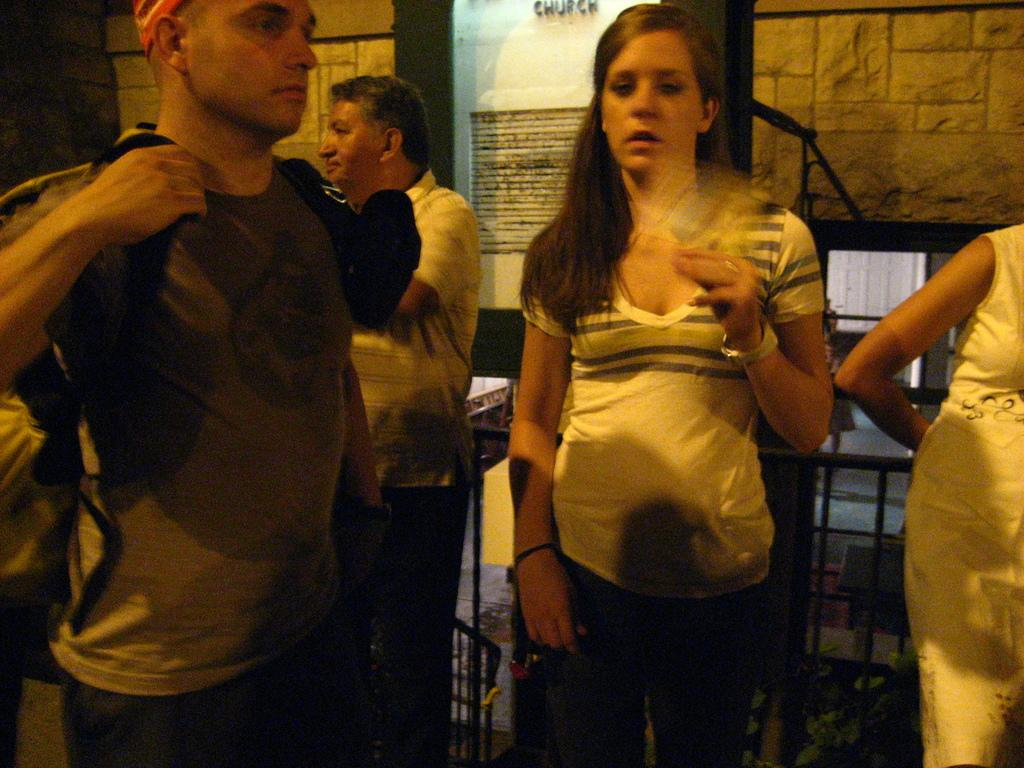What is happening in the image? There is a group of people standing in the image. What can be seen in the background of the image? There is a wallboard and tables in the background of the image, along with other objects. How many ladybugs are crawling on the wallboard in the image? There are no ladybugs visible in the image; the wallboard and other objects are the focus. 